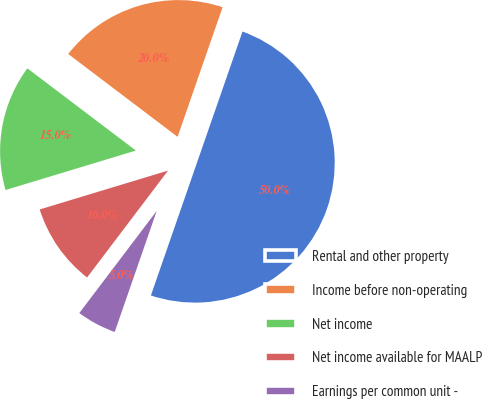Convert chart. <chart><loc_0><loc_0><loc_500><loc_500><pie_chart><fcel>Rental and other property<fcel>Income before non-operating<fcel>Net income<fcel>Net income available for MAALP<fcel>Earnings per common unit -<nl><fcel>50.0%<fcel>20.0%<fcel>15.0%<fcel>10.0%<fcel>5.0%<nl></chart> 